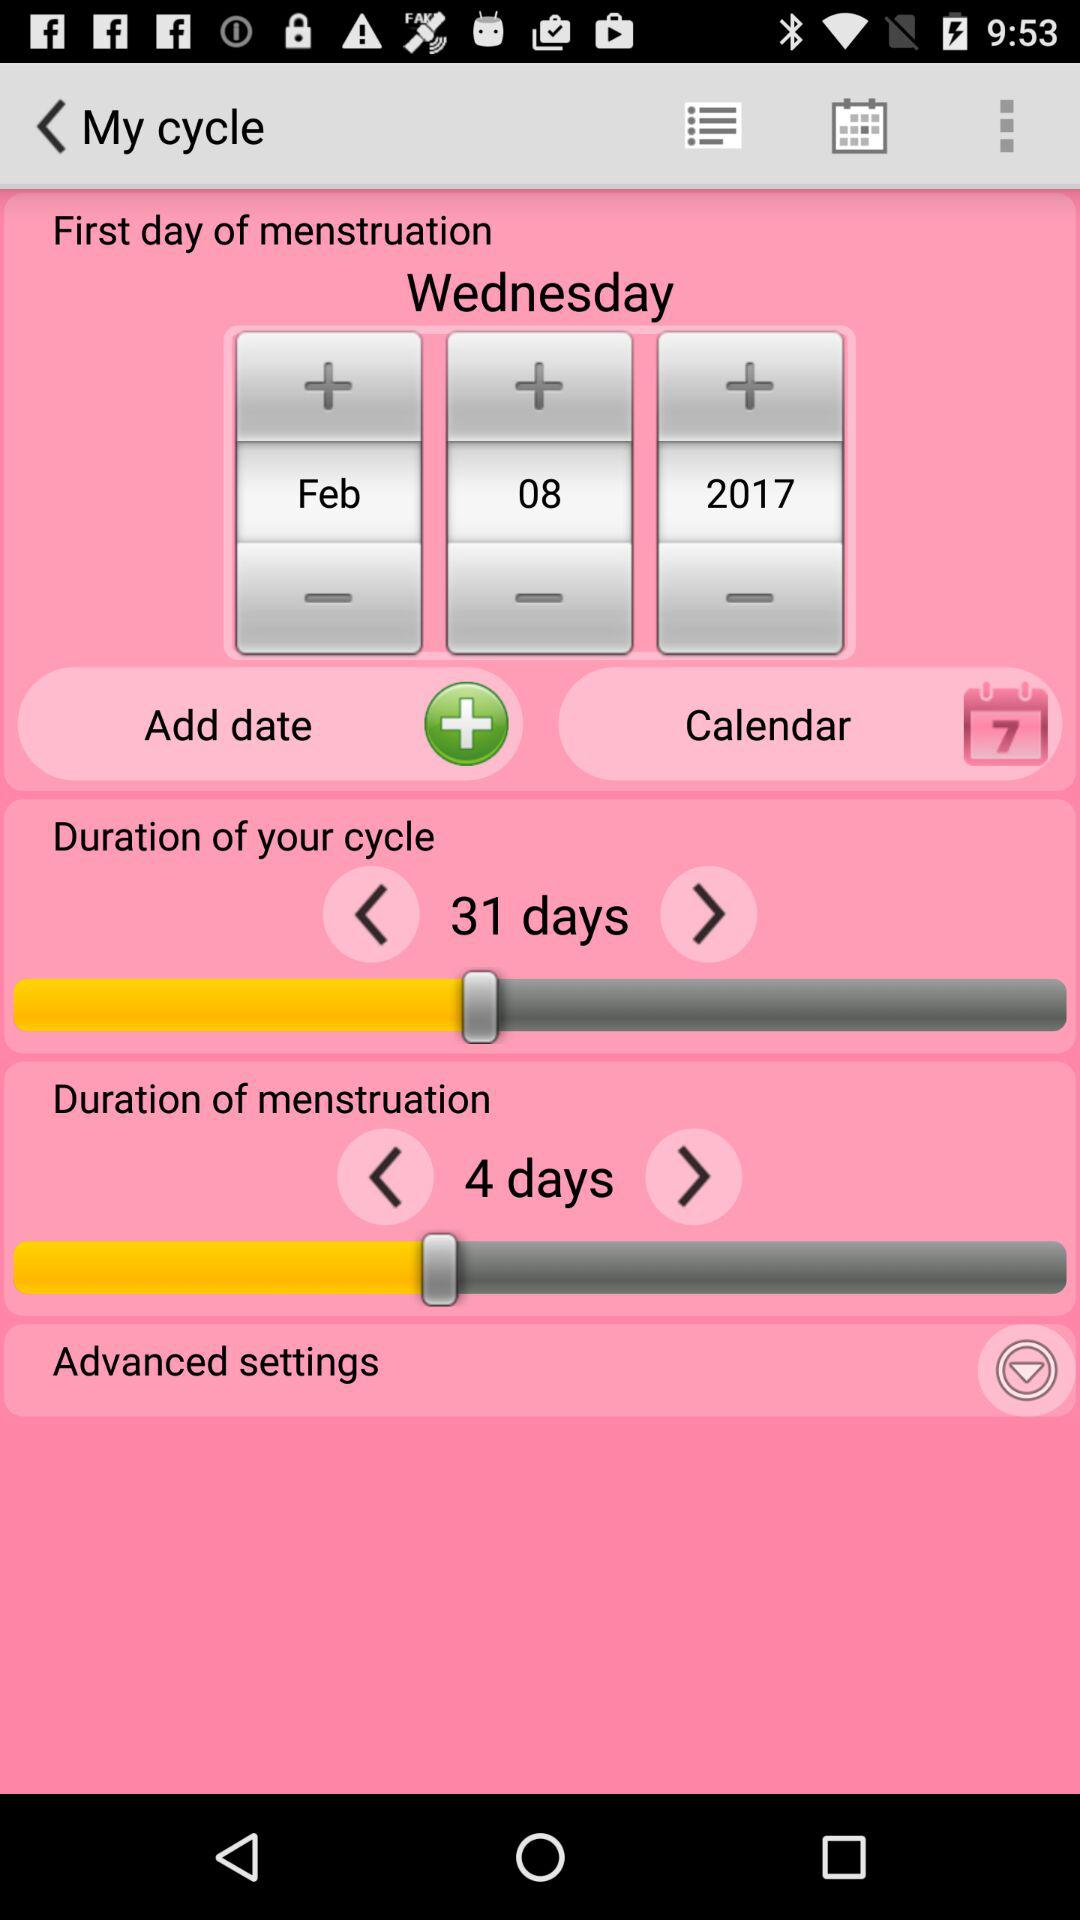What day is on February 8, 2017? The day is "Wednesday". 